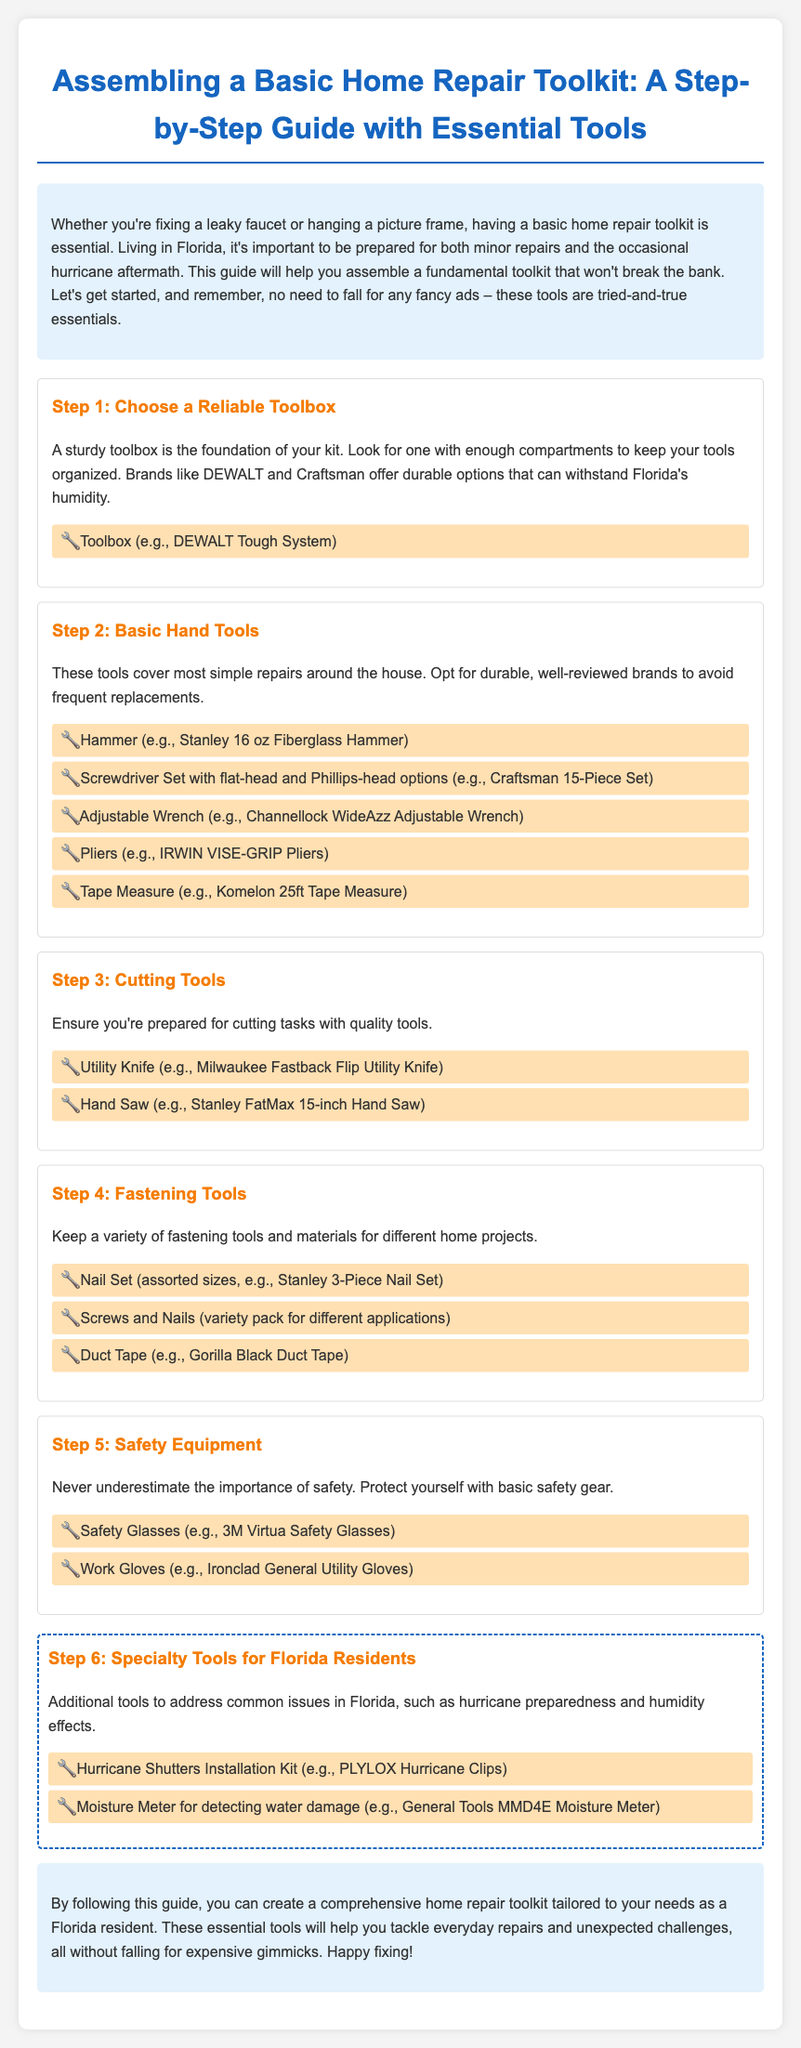What is the first step in assembling the toolkit? The document outlines the order of steps, with the first being "Choose a Reliable Toolbox."
Answer: Choose a Reliable Toolbox Which tool brand is mentioned for the toolbox? The document lists DEWALT and Craftsman as reliable brands for toolboxes.
Answer: DEWALT What should you include in your safety equipment? The document recommends Safety Glasses and Work Gloves as basic safety gear.
Answer: Safety Glasses How many basic hand tools are listed in Step 2? The document includes five specific tools under Step 2.
Answer: Five What is a specialty tool recommended for hurricane preparedness? The document specifies the Hurricane Shutters Installation Kit as essential for Florida residents.
Answer: Hurricane Shutters Installation Kit Which tool is suggested for detecting water damage? The document mentions a Moisture Meter for this purpose.
Answer: Moisture Meter What color is the background of the introduction section? The document describes the introduction section as having a light blue background.
Answer: Light blue What is the primary purpose of this toolkit? The document states that the toolkit is essential for fixing minor repairs around the house and addressing hurricane aftermath.
Answer: Minor repairs and hurricane aftermath 